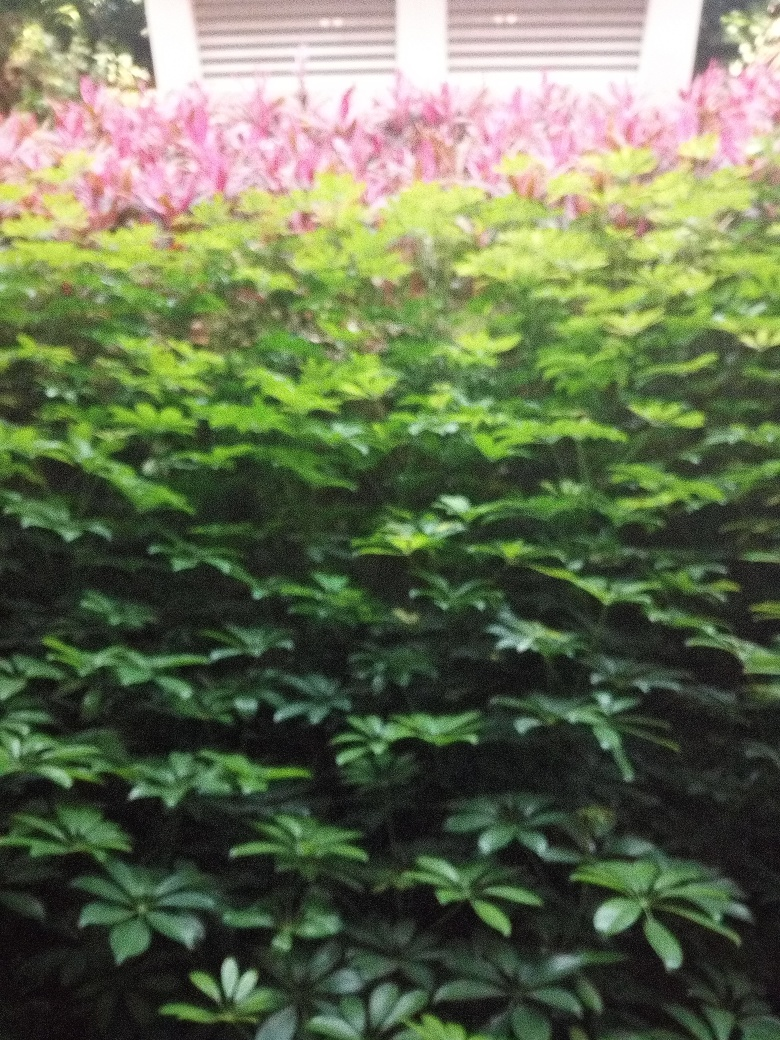Is there heavy graininess in the image?
 Yes 